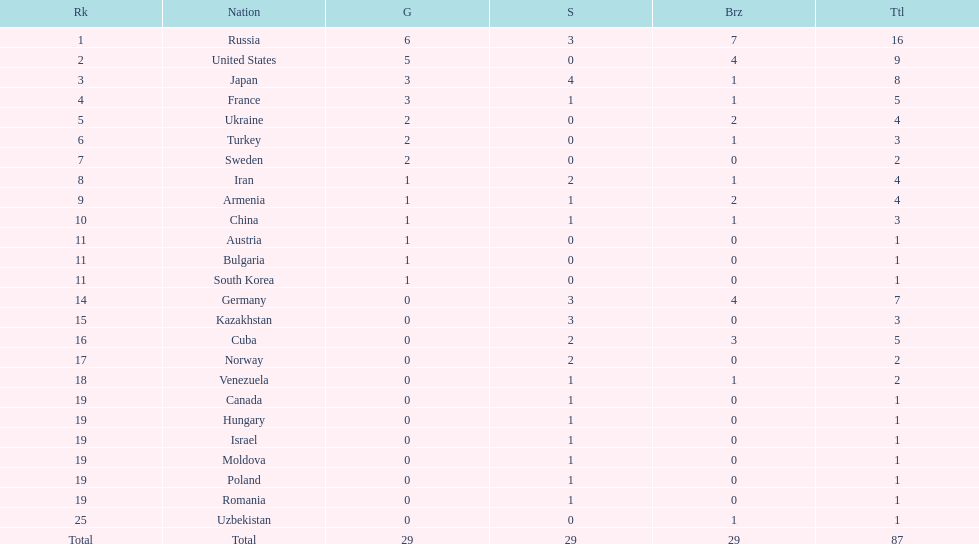Was either iran or germany not included in the top 10 nations? Germany. 